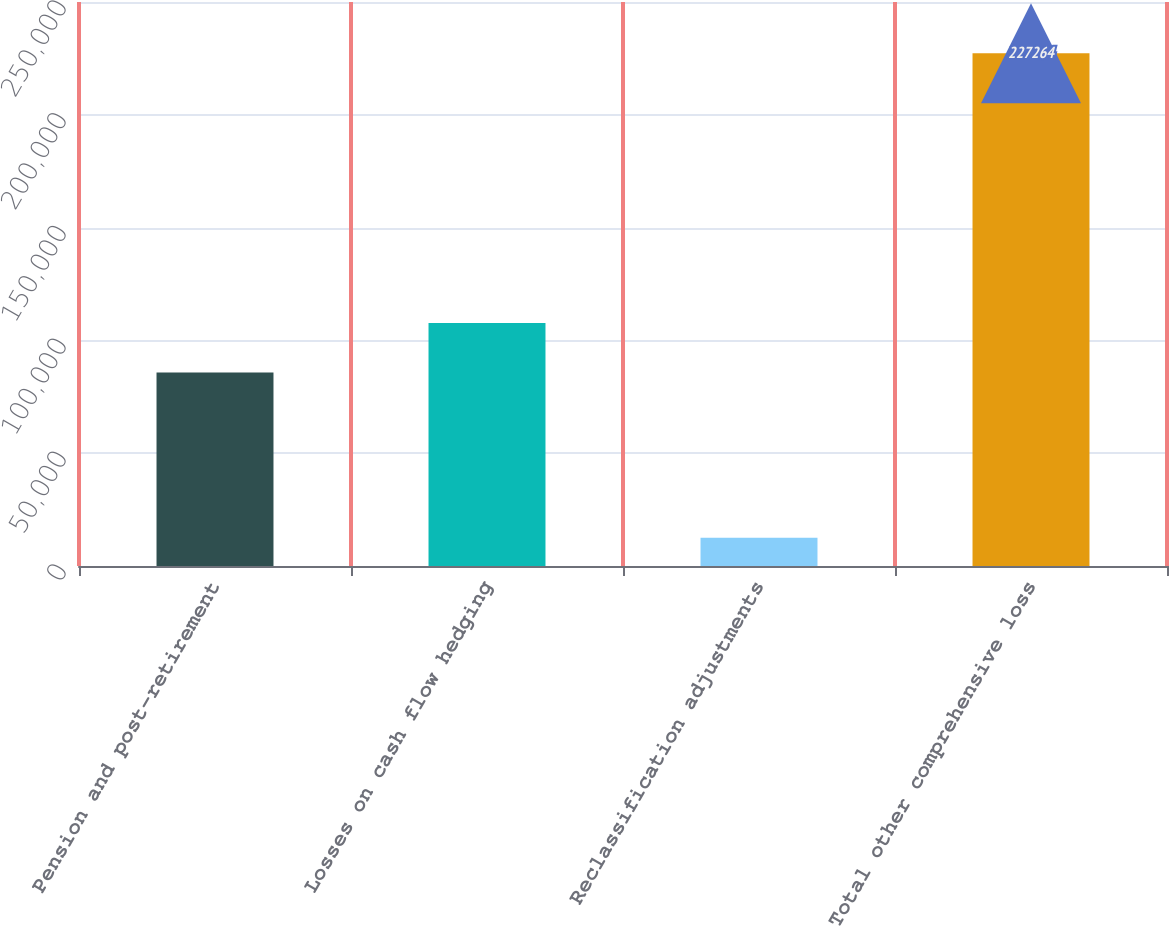Convert chart. <chart><loc_0><loc_0><loc_500><loc_500><bar_chart><fcel>Pension and post-retirement<fcel>Losses on cash flow hedging<fcel>Reclassification adjustments<fcel>Total other comprehensive loss<nl><fcel>85823<fcel>107713<fcel>12515<fcel>227264<nl></chart> 